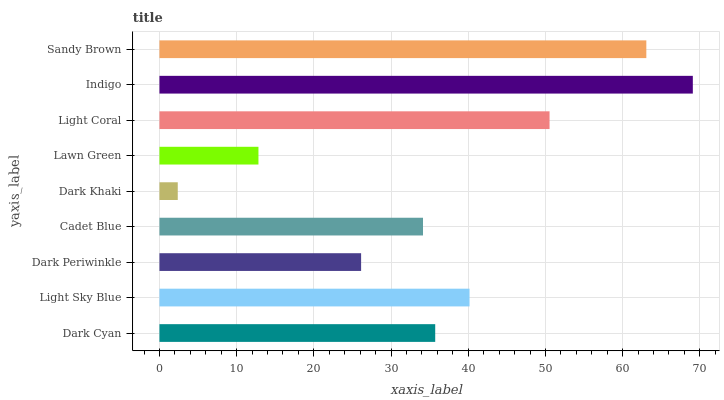Is Dark Khaki the minimum?
Answer yes or no. Yes. Is Indigo the maximum?
Answer yes or no. Yes. Is Light Sky Blue the minimum?
Answer yes or no. No. Is Light Sky Blue the maximum?
Answer yes or no. No. Is Light Sky Blue greater than Dark Cyan?
Answer yes or no. Yes. Is Dark Cyan less than Light Sky Blue?
Answer yes or no. Yes. Is Dark Cyan greater than Light Sky Blue?
Answer yes or no. No. Is Light Sky Blue less than Dark Cyan?
Answer yes or no. No. Is Dark Cyan the high median?
Answer yes or no. Yes. Is Dark Cyan the low median?
Answer yes or no. Yes. Is Dark Periwinkle the high median?
Answer yes or no. No. Is Indigo the low median?
Answer yes or no. No. 